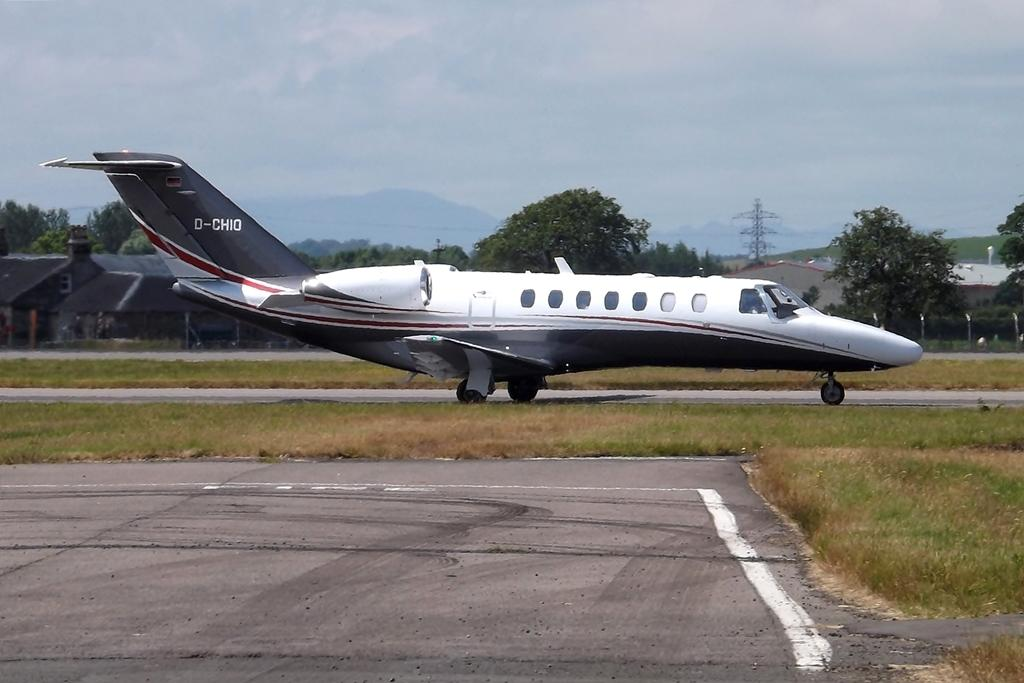<image>
Create a compact narrative representing the image presented. D-CHIO is the flight number painted onto the side of this passenger jet. 